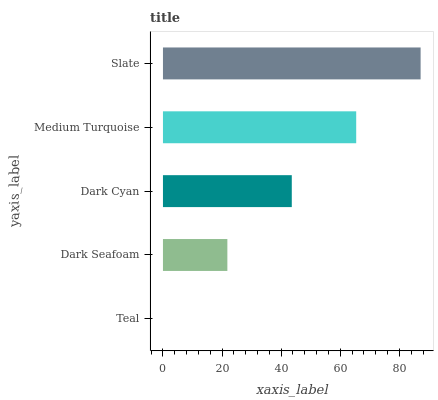Is Teal the minimum?
Answer yes or no. Yes. Is Slate the maximum?
Answer yes or no. Yes. Is Dark Seafoam the minimum?
Answer yes or no. No. Is Dark Seafoam the maximum?
Answer yes or no. No. Is Dark Seafoam greater than Teal?
Answer yes or no. Yes. Is Teal less than Dark Seafoam?
Answer yes or no. Yes. Is Teal greater than Dark Seafoam?
Answer yes or no. No. Is Dark Seafoam less than Teal?
Answer yes or no. No. Is Dark Cyan the high median?
Answer yes or no. Yes. Is Dark Cyan the low median?
Answer yes or no. Yes. Is Slate the high median?
Answer yes or no. No. Is Slate the low median?
Answer yes or no. No. 